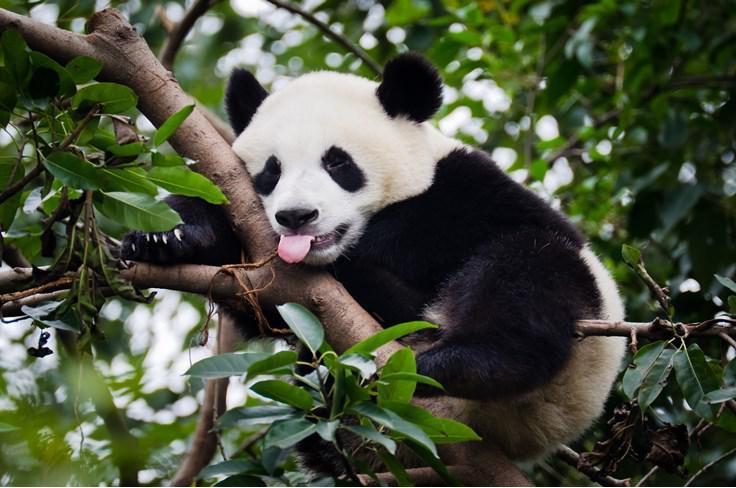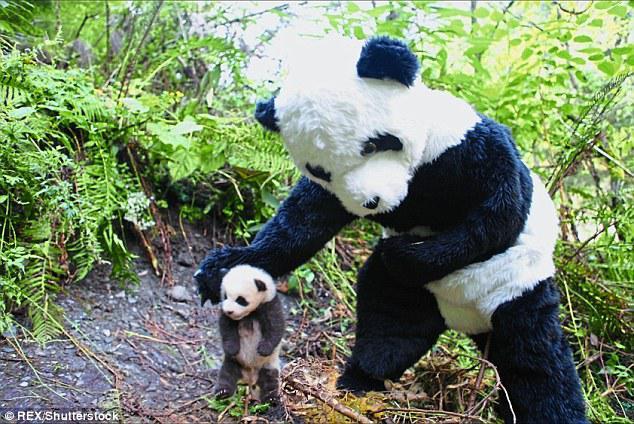The first image is the image on the left, the second image is the image on the right. Analyze the images presented: Is the assertion "In one image, a standing panda figure on the right is looking down toward another panda, and in the other image, the mouth of a panda with its body turned leftward and its face forward is next to leafy foliage." valid? Answer yes or no. Yes. The first image is the image on the left, the second image is the image on the right. Analyze the images presented: Is the assertion "There are two different animal species in the right image." valid? Answer yes or no. Yes. 